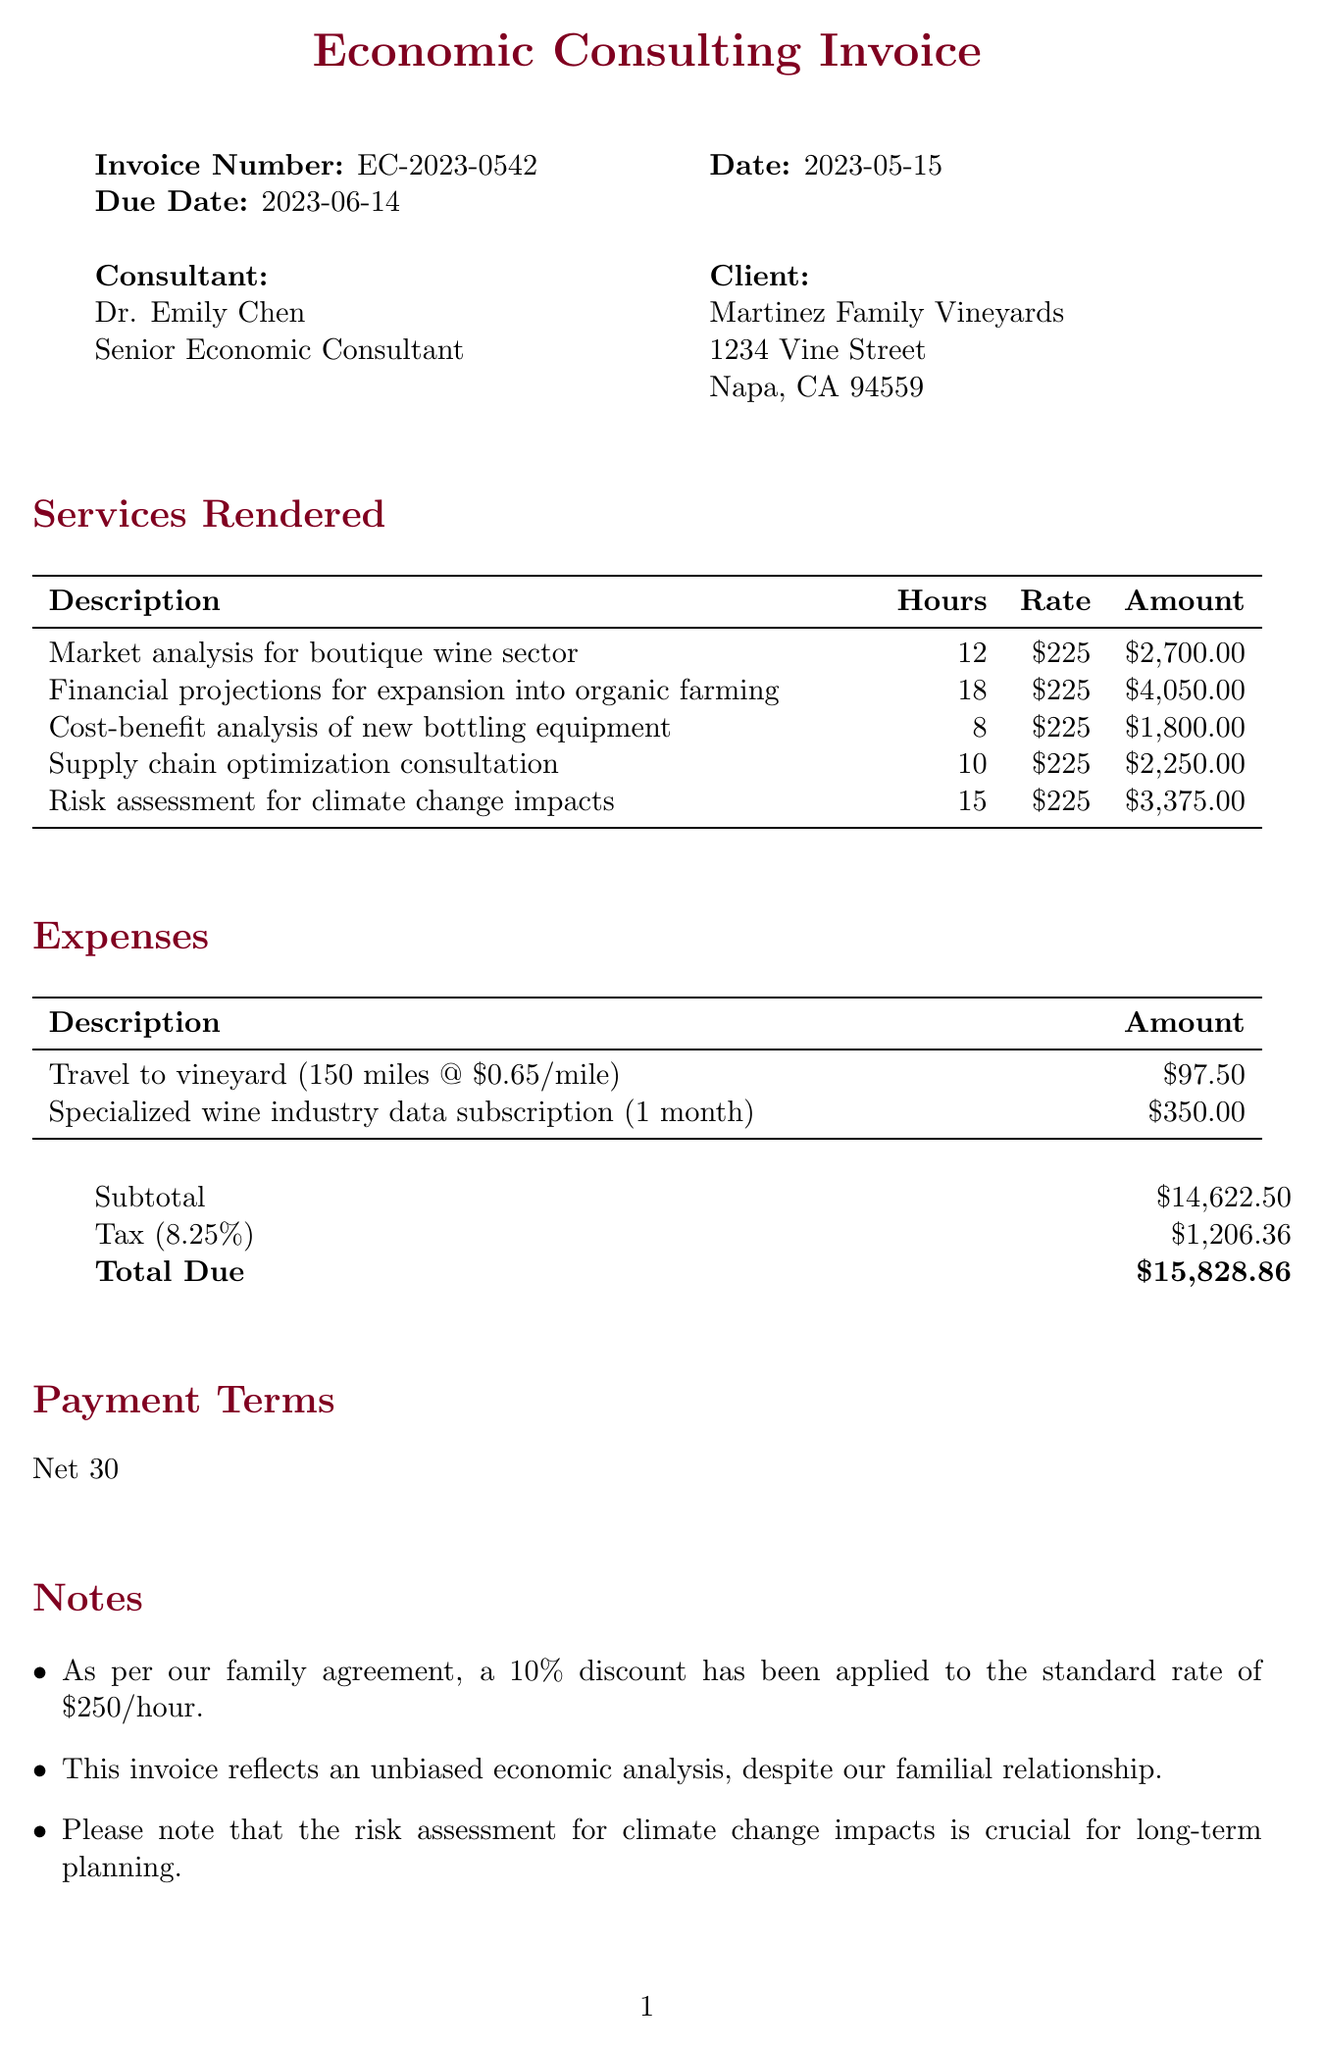What is the invoice number? The invoice number is a specific identifier for the document, found in the invoice details section.
Answer: EC-2023-0542 Who is the consultant? The consultant's name is mentioned at the top of the invoice under the consultant section.
Answer: Dr. Emily Chen What is the total due amount? The total due amount is calculated from subtotal and tax, stated at the end of the invoice.
Answer: 15828.86 How many hours were billed for the supply chain optimization consultation? The hours billed for each service are listed in the services rendered section.
Answer: 10 What is the tax rate applied? The tax rate is a percentage stated in the subtotal and totals section of the invoice.
Answer: 8.25% What was the reason for applying a discount? The discount is explained in the notes section of the invoice.
Answer: Family agreement What is the due date for payment? The due date is specified in the invoice details section.
Answer: 2023-06-14 How much was spent on the specialized wine industry data subscription? The amount spent is detailed in the expenses section of the invoice.
Answer: 350 What payment terms are specified in the invoice? The payment terms indicate when the payment is expected and are noted at the bottom of the invoice.
Answer: Net 30 